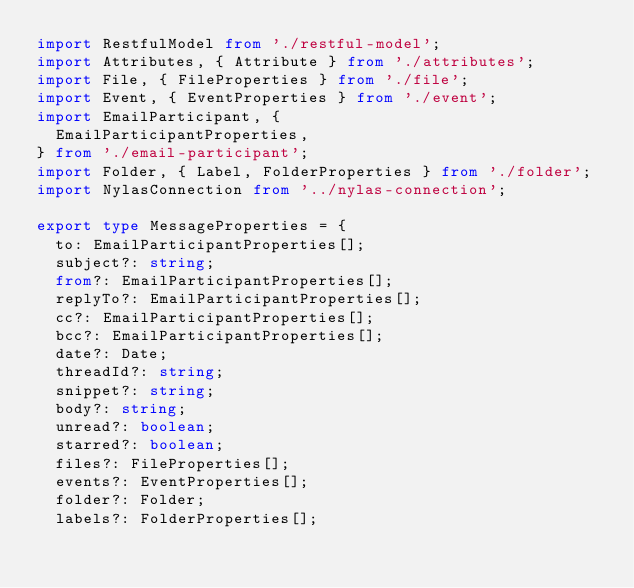<code> <loc_0><loc_0><loc_500><loc_500><_TypeScript_>import RestfulModel from './restful-model';
import Attributes, { Attribute } from './attributes';
import File, { FileProperties } from './file';
import Event, { EventProperties } from './event';
import EmailParticipant, {
  EmailParticipantProperties,
} from './email-participant';
import Folder, { Label, FolderProperties } from './folder';
import NylasConnection from '../nylas-connection';

export type MessageProperties = {
  to: EmailParticipantProperties[];
  subject?: string;
  from?: EmailParticipantProperties[];
  replyTo?: EmailParticipantProperties[];
  cc?: EmailParticipantProperties[];
  bcc?: EmailParticipantProperties[];
  date?: Date;
  threadId?: string;
  snippet?: string;
  body?: string;
  unread?: boolean;
  starred?: boolean;
  files?: FileProperties[];
  events?: EventProperties[];
  folder?: Folder;
  labels?: FolderProperties[];</code> 